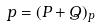<formula> <loc_0><loc_0><loc_500><loc_500>p = ( P + Q ) _ { p }</formula> 